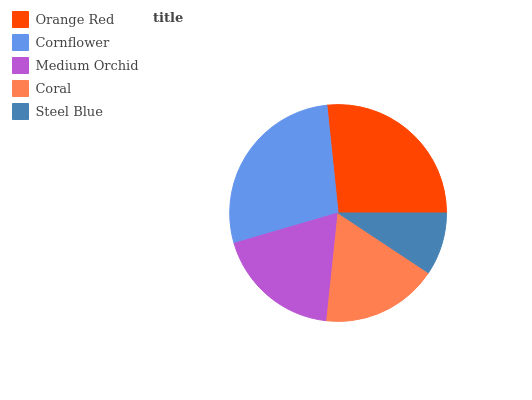Is Steel Blue the minimum?
Answer yes or no. Yes. Is Cornflower the maximum?
Answer yes or no. Yes. Is Medium Orchid the minimum?
Answer yes or no. No. Is Medium Orchid the maximum?
Answer yes or no. No. Is Cornflower greater than Medium Orchid?
Answer yes or no. Yes. Is Medium Orchid less than Cornflower?
Answer yes or no. Yes. Is Medium Orchid greater than Cornflower?
Answer yes or no. No. Is Cornflower less than Medium Orchid?
Answer yes or no. No. Is Medium Orchid the high median?
Answer yes or no. Yes. Is Medium Orchid the low median?
Answer yes or no. Yes. Is Cornflower the high median?
Answer yes or no. No. Is Steel Blue the low median?
Answer yes or no. No. 